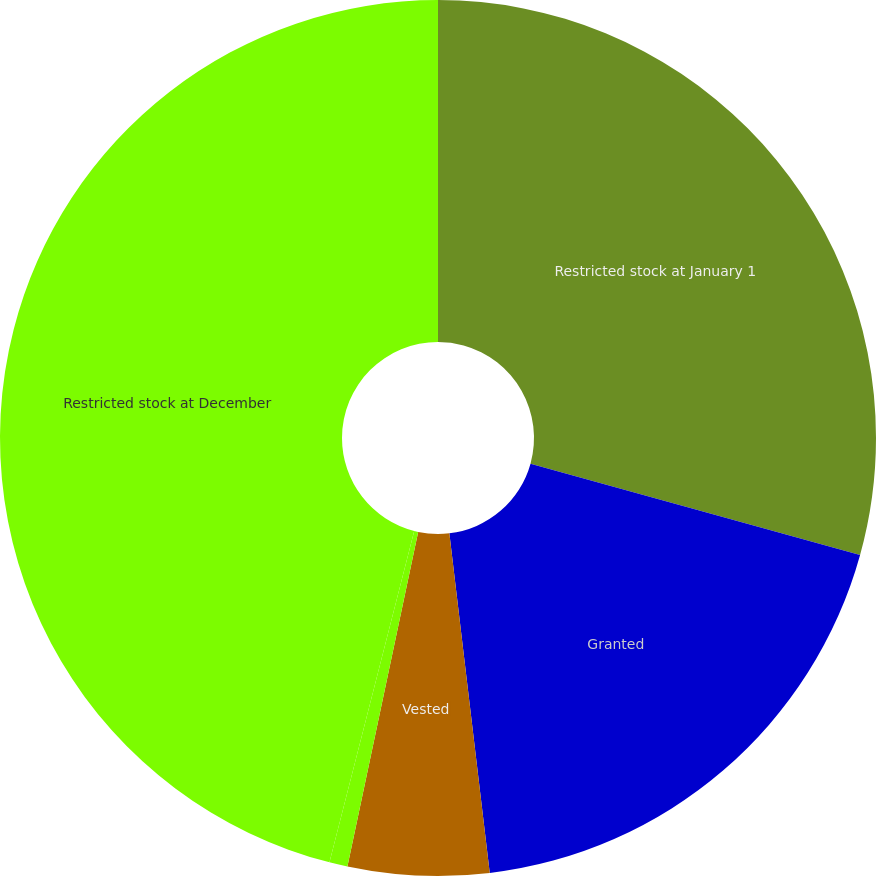Convert chart to OTSL. <chart><loc_0><loc_0><loc_500><loc_500><pie_chart><fcel>Restricted stock at January 1<fcel>Granted<fcel>Vested<fcel>Cancellations<fcel>Restricted stock at December<nl><fcel>29.3%<fcel>18.81%<fcel>5.2%<fcel>0.67%<fcel>46.01%<nl></chart> 